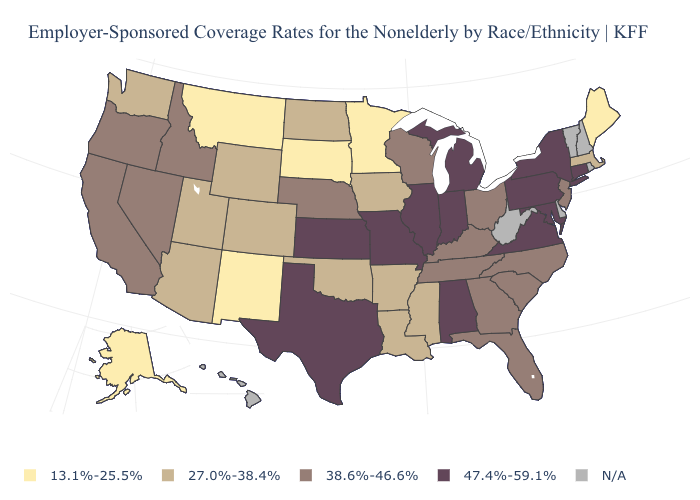Does the first symbol in the legend represent the smallest category?
Answer briefly. Yes. Which states hav the highest value in the Northeast?
Be succinct. Connecticut, New York, Pennsylvania. What is the value of Kansas?
Write a very short answer. 47.4%-59.1%. Is the legend a continuous bar?
Concise answer only. No. Name the states that have a value in the range 38.6%-46.6%?
Give a very brief answer. California, Florida, Georgia, Idaho, Kentucky, Nebraska, Nevada, New Jersey, North Carolina, Ohio, Oregon, South Carolina, Tennessee, Wisconsin. Among the states that border West Virginia , which have the lowest value?
Give a very brief answer. Kentucky, Ohio. Does Kansas have the highest value in the USA?
Be succinct. Yes. What is the value of Nevada?
Short answer required. 38.6%-46.6%. Name the states that have a value in the range 13.1%-25.5%?
Quick response, please. Alaska, Maine, Minnesota, Montana, New Mexico, South Dakota. Among the states that border Washington , which have the highest value?
Give a very brief answer. Idaho, Oregon. Name the states that have a value in the range 27.0%-38.4%?
Quick response, please. Arizona, Arkansas, Colorado, Iowa, Louisiana, Massachusetts, Mississippi, North Dakota, Oklahoma, Utah, Washington, Wyoming. Which states have the lowest value in the MidWest?
Quick response, please. Minnesota, South Dakota. Name the states that have a value in the range 47.4%-59.1%?
Short answer required. Alabama, Connecticut, Illinois, Indiana, Kansas, Maryland, Michigan, Missouri, New York, Pennsylvania, Texas, Virginia. 